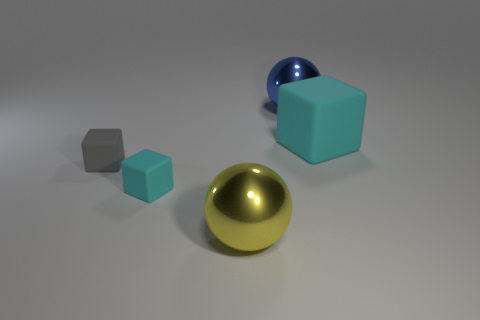Add 2 gray objects. How many objects exist? 7 Subtract all cubes. How many objects are left? 2 Subtract 2 cubes. How many cubes are left? 1 Subtract all brown spheres. Subtract all cyan cylinders. How many spheres are left? 2 Subtract all green spheres. How many yellow cubes are left? 0 Subtract all gray rubber blocks. Subtract all large cyan rubber blocks. How many objects are left? 3 Add 1 large blue spheres. How many large blue spheres are left? 2 Add 1 tiny gray rubber objects. How many tiny gray rubber objects exist? 2 Subtract all cyan blocks. How many blocks are left? 1 Subtract all small cyan blocks. How many blocks are left? 2 